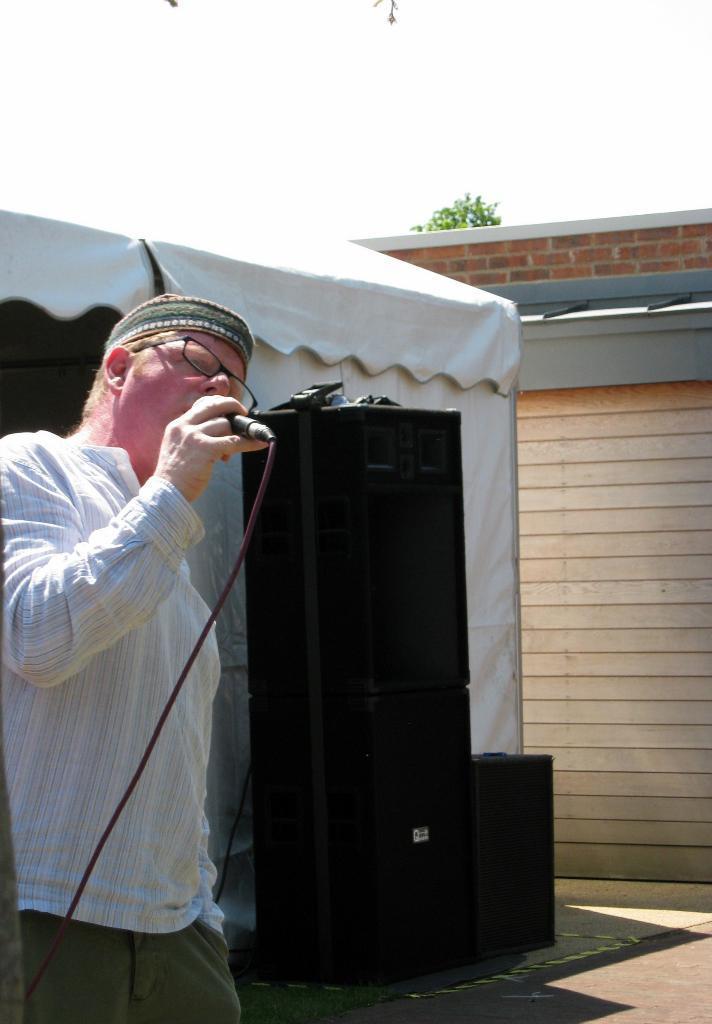Describe this image in one or two sentences. The person is standing and singing in front of a mic and there are black speakers beside him. 